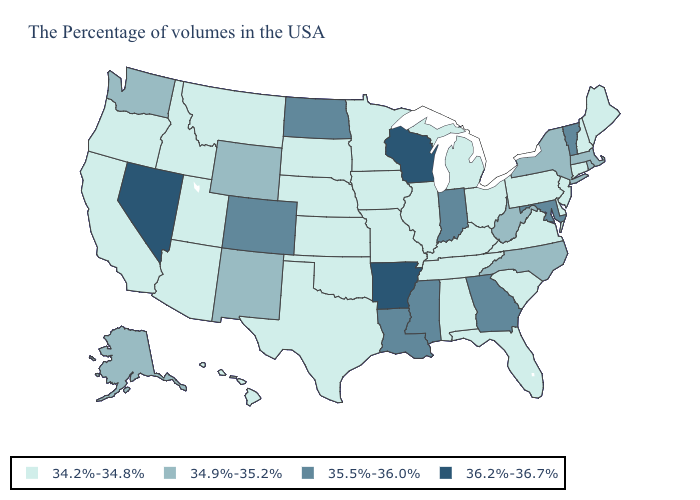Which states have the lowest value in the South?
Short answer required. Delaware, Virginia, South Carolina, Florida, Kentucky, Alabama, Tennessee, Oklahoma, Texas. Name the states that have a value in the range 35.5%-36.0%?
Quick response, please. Vermont, Maryland, Georgia, Indiana, Mississippi, Louisiana, North Dakota, Colorado. Name the states that have a value in the range 34.2%-34.8%?
Keep it brief. Maine, New Hampshire, Connecticut, New Jersey, Delaware, Pennsylvania, Virginia, South Carolina, Ohio, Florida, Michigan, Kentucky, Alabama, Tennessee, Illinois, Missouri, Minnesota, Iowa, Kansas, Nebraska, Oklahoma, Texas, South Dakota, Utah, Montana, Arizona, Idaho, California, Oregon, Hawaii. Does Georgia have a lower value than Nevada?
Short answer required. Yes. What is the value of North Dakota?
Be succinct. 35.5%-36.0%. Does West Virginia have the lowest value in the South?
Short answer required. No. Name the states that have a value in the range 34.9%-35.2%?
Quick response, please. Massachusetts, Rhode Island, New York, North Carolina, West Virginia, Wyoming, New Mexico, Washington, Alaska. Name the states that have a value in the range 36.2%-36.7%?
Quick response, please. Wisconsin, Arkansas, Nevada. Which states have the lowest value in the USA?
Answer briefly. Maine, New Hampshire, Connecticut, New Jersey, Delaware, Pennsylvania, Virginia, South Carolina, Ohio, Florida, Michigan, Kentucky, Alabama, Tennessee, Illinois, Missouri, Minnesota, Iowa, Kansas, Nebraska, Oklahoma, Texas, South Dakota, Utah, Montana, Arizona, Idaho, California, Oregon, Hawaii. Does Minnesota have the highest value in the MidWest?
Answer briefly. No. What is the lowest value in the South?
Concise answer only. 34.2%-34.8%. Name the states that have a value in the range 34.2%-34.8%?
Short answer required. Maine, New Hampshire, Connecticut, New Jersey, Delaware, Pennsylvania, Virginia, South Carolina, Ohio, Florida, Michigan, Kentucky, Alabama, Tennessee, Illinois, Missouri, Minnesota, Iowa, Kansas, Nebraska, Oklahoma, Texas, South Dakota, Utah, Montana, Arizona, Idaho, California, Oregon, Hawaii. Among the states that border Minnesota , does Wisconsin have the highest value?
Concise answer only. Yes. Which states have the lowest value in the South?
Give a very brief answer. Delaware, Virginia, South Carolina, Florida, Kentucky, Alabama, Tennessee, Oklahoma, Texas. Does the map have missing data?
Give a very brief answer. No. 